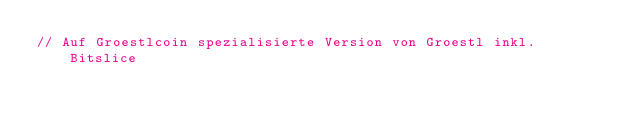Convert code to text. <code><loc_0><loc_0><loc_500><loc_500><_Cuda_>// Auf Groestlcoin spezialisierte Version von Groestl inkl. Bitslice
</code> 